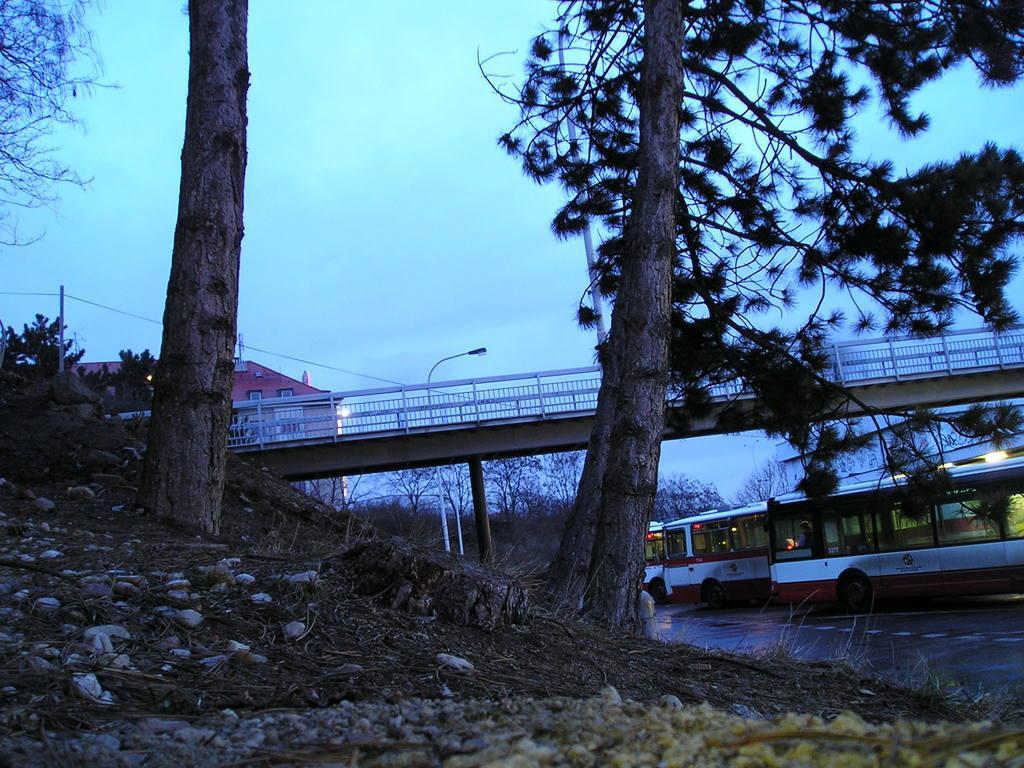Can you describe this image briefly? At the bottom, we see the flowers and the twigs. On the right side, we see the road and the vehicles are moving on the road. Behind that, we see a building. In the middle, we see a pole and a tree. Behind that, we see a street light and a bridge. On the left side, we see the stem of the tree. There are trees, buildings and the poles in the background. At the top, we see the sky. 